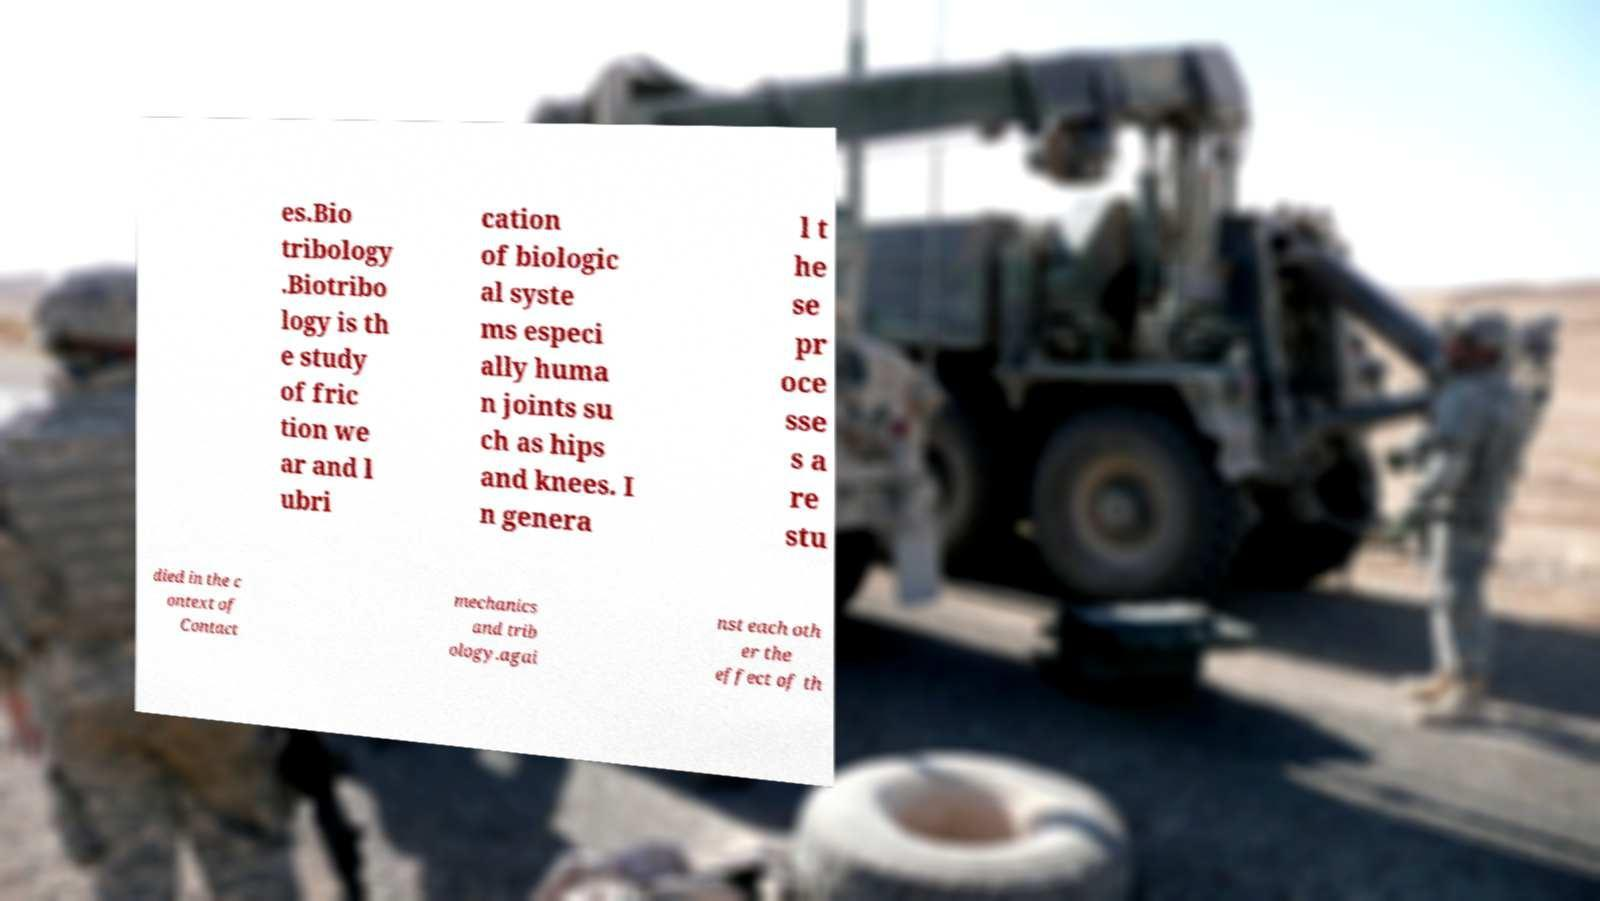I need the written content from this picture converted into text. Can you do that? es.Bio tribology .Biotribo logy is th e study of fric tion we ar and l ubri cation of biologic al syste ms especi ally huma n joints su ch as hips and knees. I n genera l t he se pr oce sse s a re stu died in the c ontext of Contact mechanics and trib ology.agai nst each oth er the effect of th 